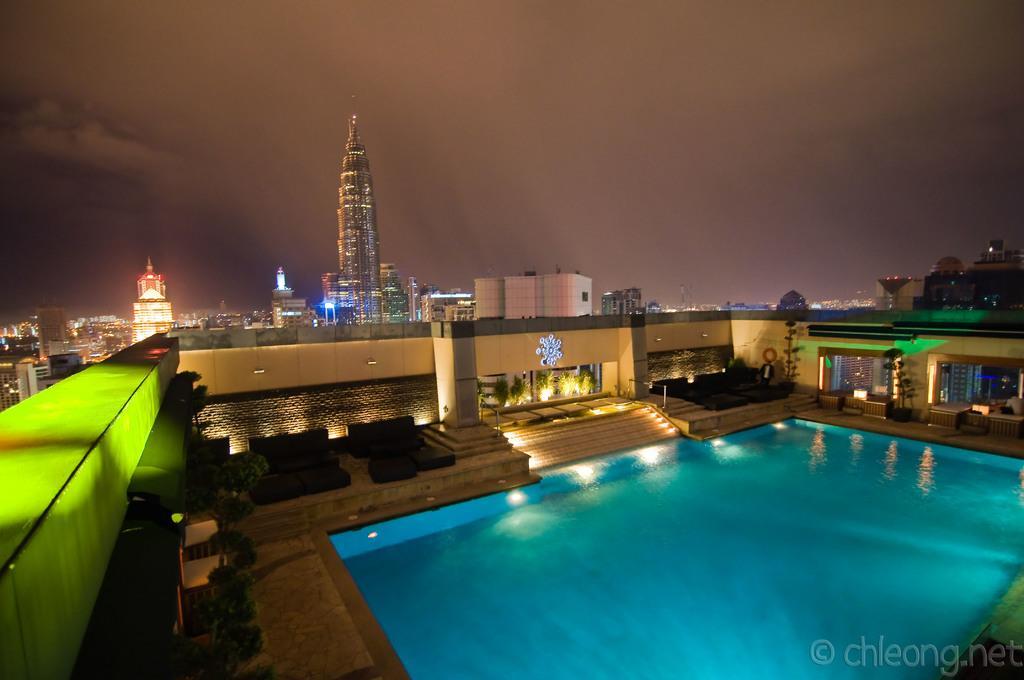In one or two sentences, can you explain what this image depicts? In this image I can see few buildings, plants, stairs, lights, sky and the pool. 